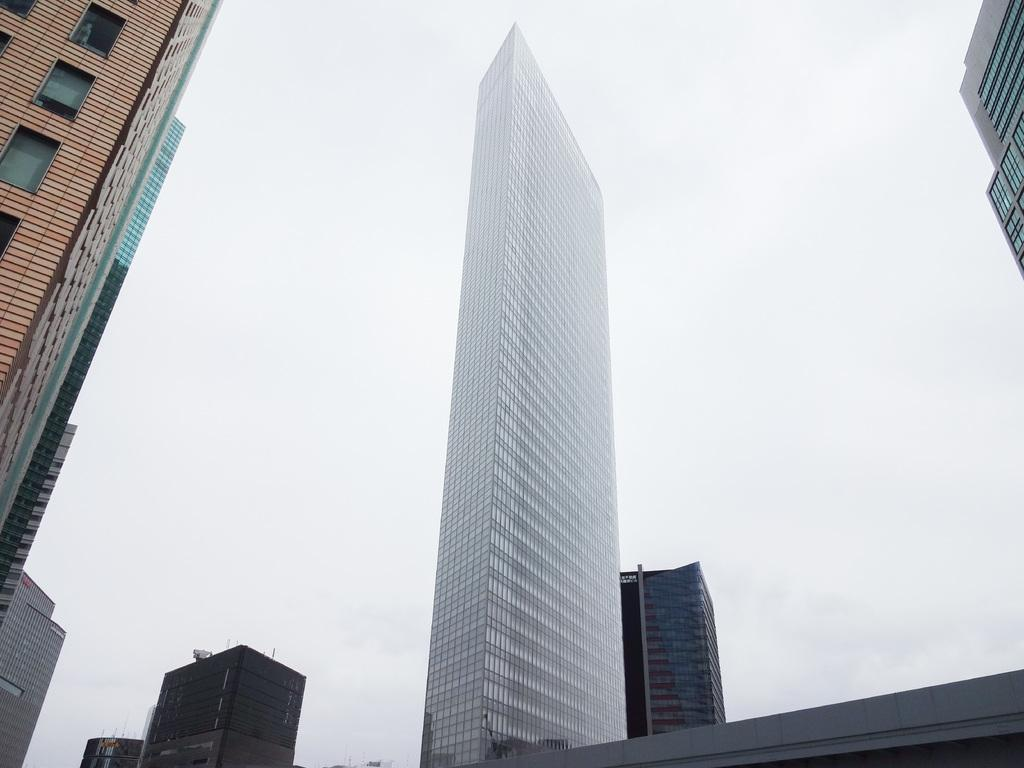What type of structures can be seen in the image? There are buildings in the image. What is the condition of the sky in the image? The sky is cloudy in the image. What type of utensil is used to say good-bye in the image? There is no utensil or good-bye gesture present in the image. What type of journey is depicted in the image? The image does not depict a voyage or any type of journey. 